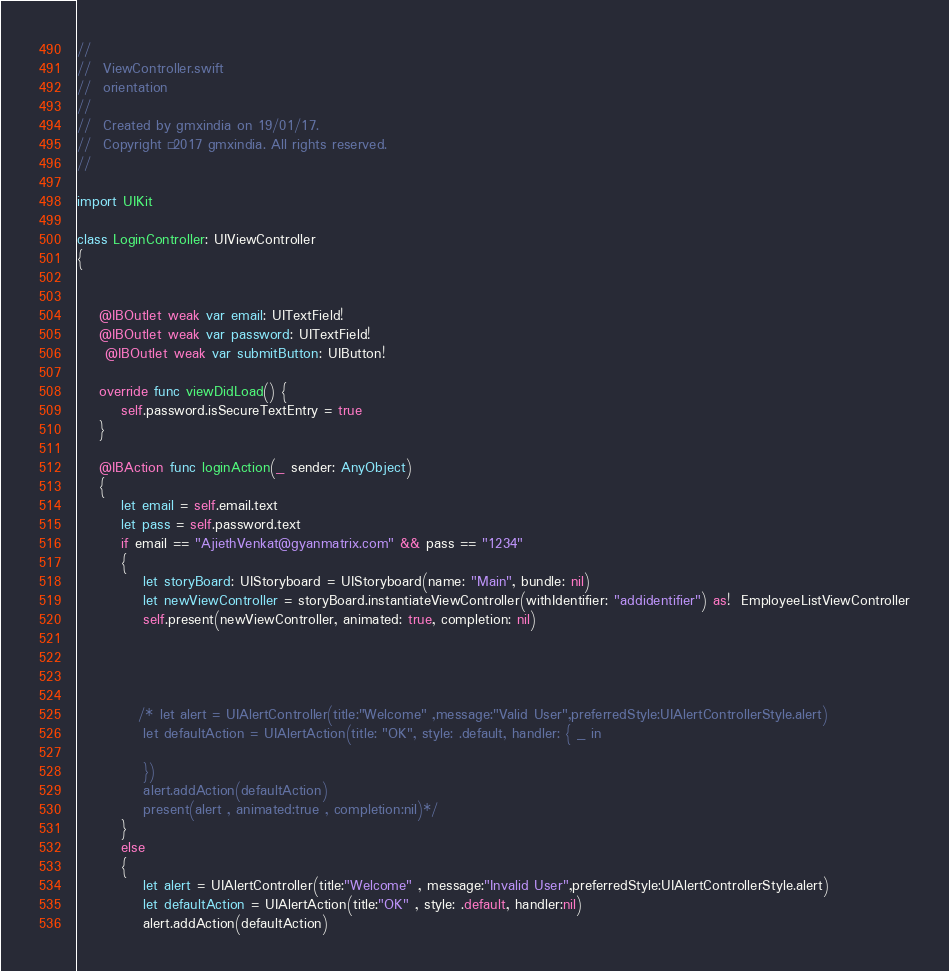Convert code to text. <code><loc_0><loc_0><loc_500><loc_500><_Swift_>//
//  ViewController.swift
//  orientation
//
//  Created by gmxindia on 19/01/17.
//  Copyright © 2017 gmxindia. All rights reserved.
//

import UIKit

class LoginController: UIViewController
{
   
    
    @IBOutlet weak var email: UITextField!
    @IBOutlet weak var password: UITextField!
     @IBOutlet weak var submitButton: UIButton!
    
    override func viewDidLoad() {
        self.password.isSecureTextEntry = true
    }
    
    @IBAction func loginAction(_ sender: AnyObject)
    {
        let email = self.email.text
        let pass = self.password.text
        if email == "AjiethVenkat@gyanmatrix.com" && pass == "1234"
        {
            let storyBoard: UIStoryboard = UIStoryboard(name: "Main", bundle: nil)
            let newViewController = storyBoard.instantiateViewController(withIdentifier: "addidentifier") as!  EmployeeListViewController
            self.present(newViewController, animated: true, completion: nil)
            
           

            
           /* let alert = UIAlertController(title:"Welcome" ,message:"Valid User",preferredStyle:UIAlertControllerStyle.alert)
            let defaultAction = UIAlertAction(title: "OK", style: .default, handler: { _ in
                
            })
            alert.addAction(defaultAction)
            present(alert , animated:true , completion:nil)*/
        }
        else
        {
            let alert = UIAlertController(title:"Welcome" , message:"Invalid User",preferredStyle:UIAlertControllerStyle.alert)
            let defaultAction = UIAlertAction(title:"OK" , style: .default, handler:nil)
            alert.addAction(defaultAction)</code> 